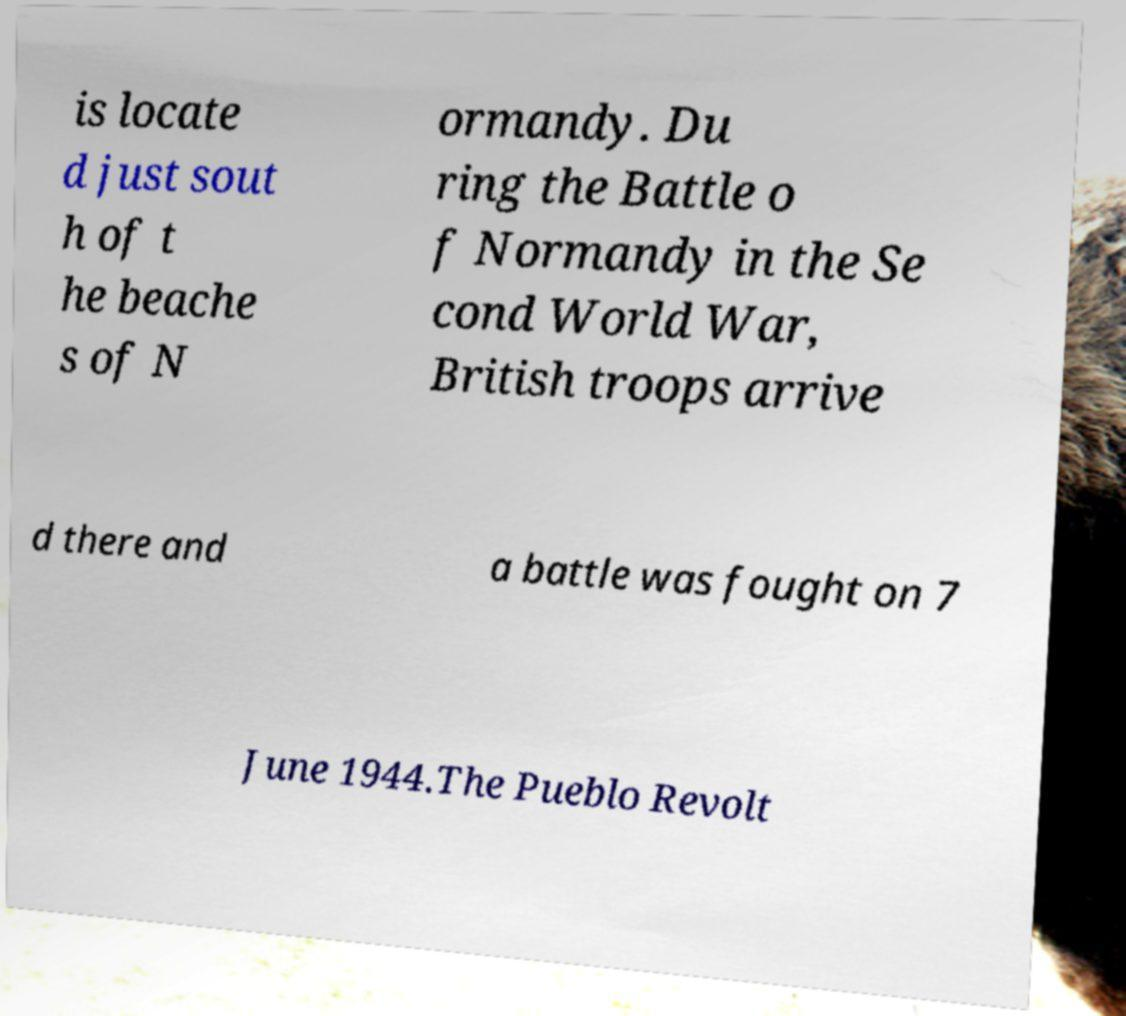Please identify and transcribe the text found in this image. is locate d just sout h of t he beache s of N ormandy. Du ring the Battle o f Normandy in the Se cond World War, British troops arrive d there and a battle was fought on 7 June 1944.The Pueblo Revolt 